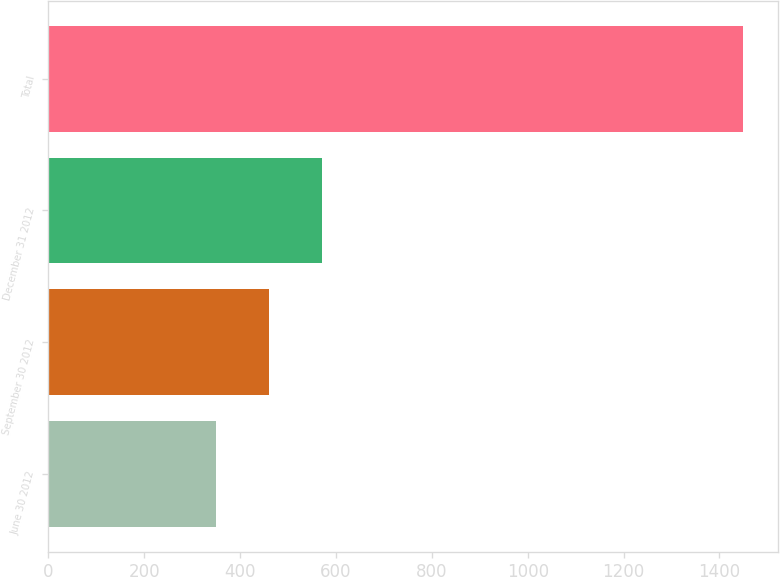Convert chart. <chart><loc_0><loc_0><loc_500><loc_500><bar_chart><fcel>June 30 2012<fcel>September 30 2012<fcel>December 31 2012<fcel>Total<nl><fcel>350<fcel>460<fcel>570<fcel>1450<nl></chart> 